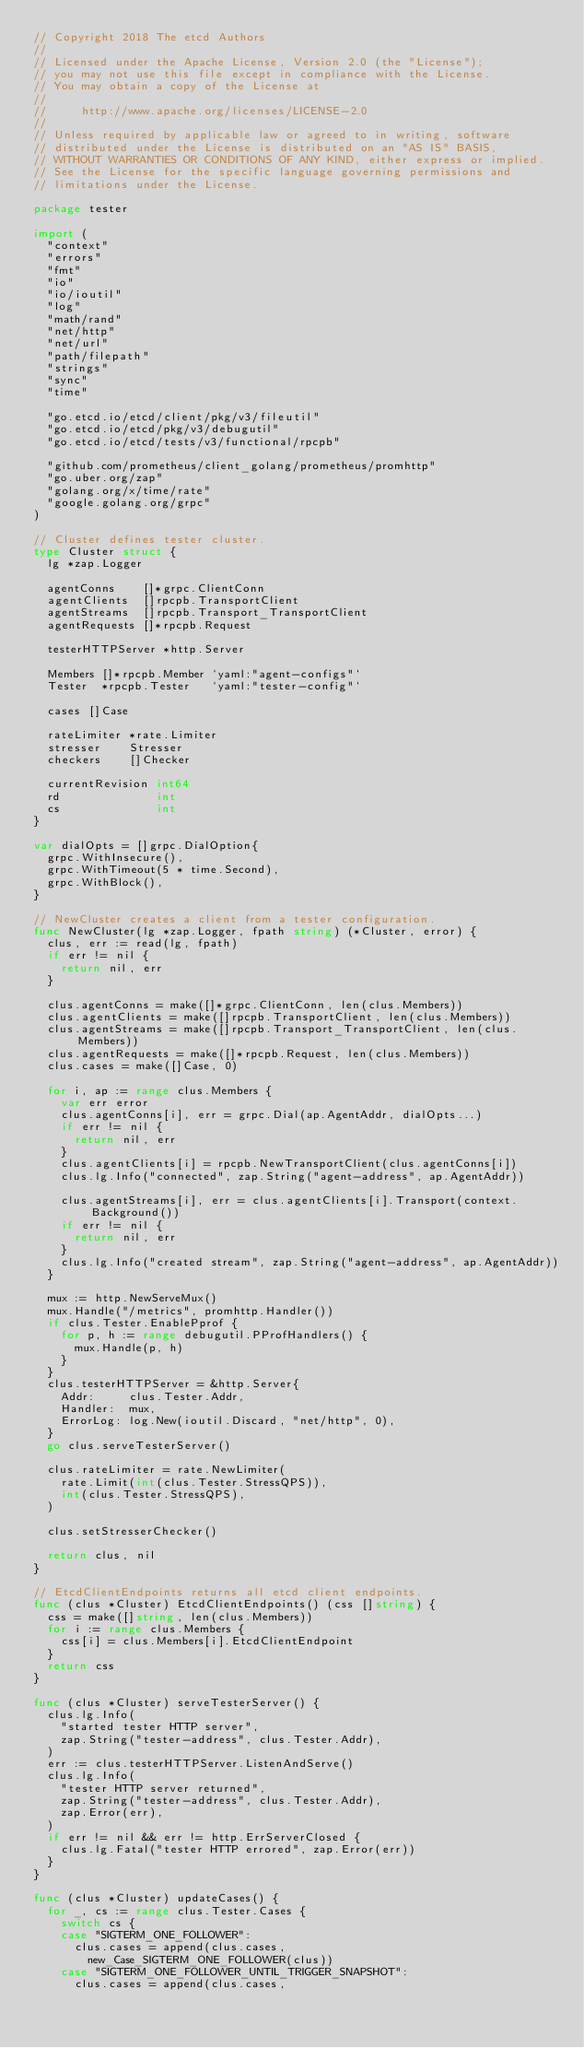<code> <loc_0><loc_0><loc_500><loc_500><_Go_>// Copyright 2018 The etcd Authors
//
// Licensed under the Apache License, Version 2.0 (the "License");
// you may not use this file except in compliance with the License.
// You may obtain a copy of the License at
//
//     http://www.apache.org/licenses/LICENSE-2.0
//
// Unless required by applicable law or agreed to in writing, software
// distributed under the License is distributed on an "AS IS" BASIS,
// WITHOUT WARRANTIES OR CONDITIONS OF ANY KIND, either express or implied.
// See the License for the specific language governing permissions and
// limitations under the License.

package tester

import (
	"context"
	"errors"
	"fmt"
	"io"
	"io/ioutil"
	"log"
	"math/rand"
	"net/http"
	"net/url"
	"path/filepath"
	"strings"
	"sync"
	"time"

	"go.etcd.io/etcd/client/pkg/v3/fileutil"
	"go.etcd.io/etcd/pkg/v3/debugutil"
	"go.etcd.io/etcd/tests/v3/functional/rpcpb"

	"github.com/prometheus/client_golang/prometheus/promhttp"
	"go.uber.org/zap"
	"golang.org/x/time/rate"
	"google.golang.org/grpc"
)

// Cluster defines tester cluster.
type Cluster struct {
	lg *zap.Logger

	agentConns    []*grpc.ClientConn
	agentClients  []rpcpb.TransportClient
	agentStreams  []rpcpb.Transport_TransportClient
	agentRequests []*rpcpb.Request

	testerHTTPServer *http.Server

	Members []*rpcpb.Member `yaml:"agent-configs"`
	Tester  *rpcpb.Tester   `yaml:"tester-config"`

	cases []Case

	rateLimiter *rate.Limiter
	stresser    Stresser
	checkers    []Checker

	currentRevision int64
	rd              int
	cs              int
}

var dialOpts = []grpc.DialOption{
	grpc.WithInsecure(),
	grpc.WithTimeout(5 * time.Second),
	grpc.WithBlock(),
}

// NewCluster creates a client from a tester configuration.
func NewCluster(lg *zap.Logger, fpath string) (*Cluster, error) {
	clus, err := read(lg, fpath)
	if err != nil {
		return nil, err
	}

	clus.agentConns = make([]*grpc.ClientConn, len(clus.Members))
	clus.agentClients = make([]rpcpb.TransportClient, len(clus.Members))
	clus.agentStreams = make([]rpcpb.Transport_TransportClient, len(clus.Members))
	clus.agentRequests = make([]*rpcpb.Request, len(clus.Members))
	clus.cases = make([]Case, 0)

	for i, ap := range clus.Members {
		var err error
		clus.agentConns[i], err = grpc.Dial(ap.AgentAddr, dialOpts...)
		if err != nil {
			return nil, err
		}
		clus.agentClients[i] = rpcpb.NewTransportClient(clus.agentConns[i])
		clus.lg.Info("connected", zap.String("agent-address", ap.AgentAddr))

		clus.agentStreams[i], err = clus.agentClients[i].Transport(context.Background())
		if err != nil {
			return nil, err
		}
		clus.lg.Info("created stream", zap.String("agent-address", ap.AgentAddr))
	}

	mux := http.NewServeMux()
	mux.Handle("/metrics", promhttp.Handler())
	if clus.Tester.EnablePprof {
		for p, h := range debugutil.PProfHandlers() {
			mux.Handle(p, h)
		}
	}
	clus.testerHTTPServer = &http.Server{
		Addr:     clus.Tester.Addr,
		Handler:  mux,
		ErrorLog: log.New(ioutil.Discard, "net/http", 0),
	}
	go clus.serveTesterServer()

	clus.rateLimiter = rate.NewLimiter(
		rate.Limit(int(clus.Tester.StressQPS)),
		int(clus.Tester.StressQPS),
	)

	clus.setStresserChecker()

	return clus, nil
}

// EtcdClientEndpoints returns all etcd client endpoints.
func (clus *Cluster) EtcdClientEndpoints() (css []string) {
	css = make([]string, len(clus.Members))
	for i := range clus.Members {
		css[i] = clus.Members[i].EtcdClientEndpoint
	}
	return css
}

func (clus *Cluster) serveTesterServer() {
	clus.lg.Info(
		"started tester HTTP server",
		zap.String("tester-address", clus.Tester.Addr),
	)
	err := clus.testerHTTPServer.ListenAndServe()
	clus.lg.Info(
		"tester HTTP server returned",
		zap.String("tester-address", clus.Tester.Addr),
		zap.Error(err),
	)
	if err != nil && err != http.ErrServerClosed {
		clus.lg.Fatal("tester HTTP errored", zap.Error(err))
	}
}

func (clus *Cluster) updateCases() {
	for _, cs := range clus.Tester.Cases {
		switch cs {
		case "SIGTERM_ONE_FOLLOWER":
			clus.cases = append(clus.cases,
				new_Case_SIGTERM_ONE_FOLLOWER(clus))
		case "SIGTERM_ONE_FOLLOWER_UNTIL_TRIGGER_SNAPSHOT":
			clus.cases = append(clus.cases,</code> 